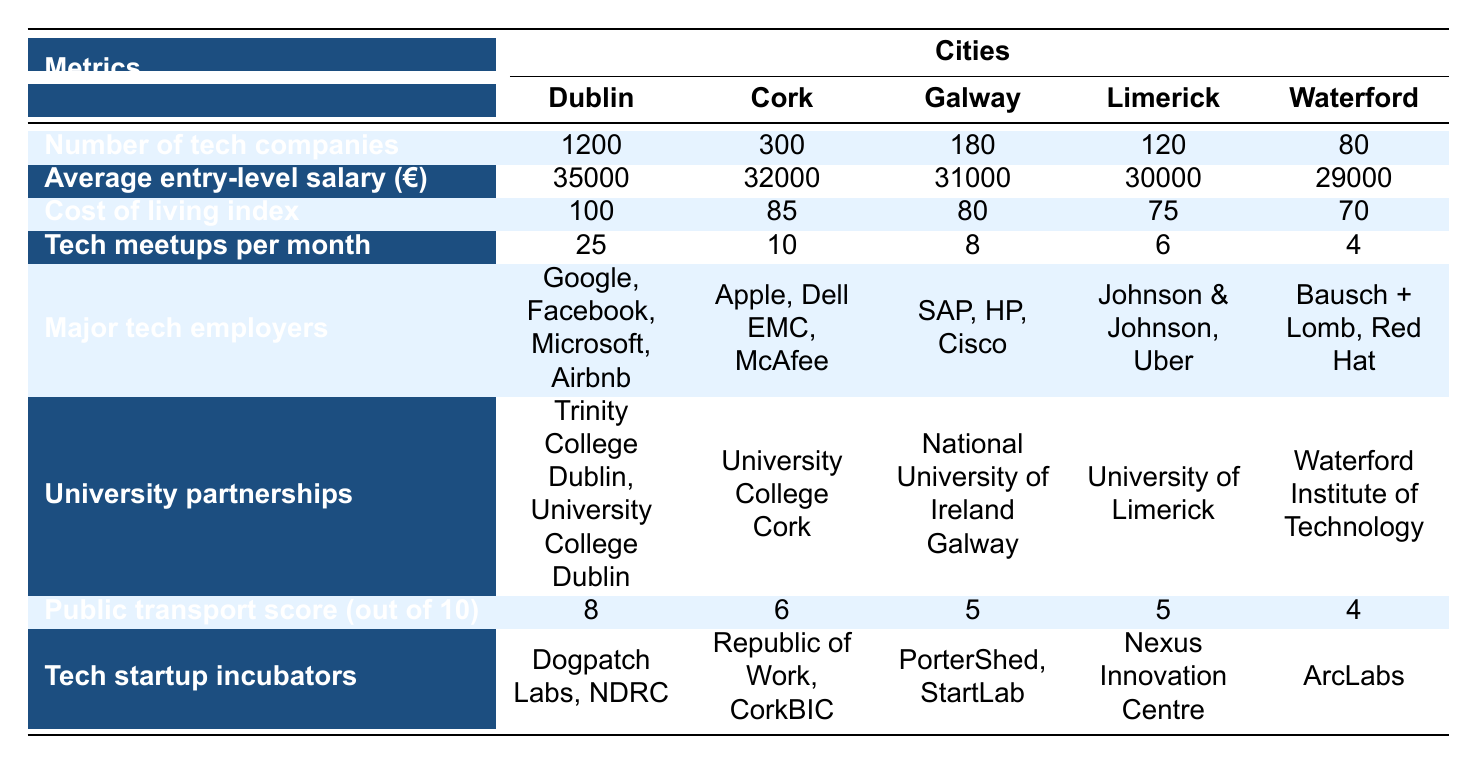What city has the highest number of tech companies? The table shows that Dublin has 1200 tech companies, which is higher than Cork (300), Galway (180), Limerick (120), and Waterford (80). Thus, Dublin has the highest number.
Answer: Dublin What is the average entry-level salary in Galway? The table indicates that the average entry-level salary in Galway is 31000 euros.
Answer: 31000 euros Is the cost of living index in Waterford lower than in Limerick? The table shows that Waterford has a cost of living index of 70 while Limerick's is 75. Since 70 is less than 75, the statement is true.
Answer: Yes How many tech meetups per month does Cork have compared to Dublin? Cork has 10 tech meetups per month, while Dublin has 25. The difference is 25 - 10 = 15, so Dublin has 15 more meetups than Cork.
Answer: 15 more meetups Which city has the worst public transport score? The public transport scores are: Dublin (8), Cork (6), Galway (5), Limerick (5), and Waterford (4). Waterford has the lowest score of 4, making it the city with the worst public transport score.
Answer: Waterford What is the average cost of living index of the cities in the table? The cost of living indices are: Dublin (100), Cork (85), Galway (80), Limerick (75), and Waterford (70). Summing these values gives 100 + 85 + 80 + 75 + 70 = 410, and dividing by 5 cities gives an average of 410 / 5 = 82.
Answer: 82 Does Cork have more tech startup incubators than Waterford? Cork has 2 tech startup incubators (Republic of Work, CorkBIC), while Waterford has 1 (ArcLabs). Since 2 is greater than 1, the statement is true.
Answer: Yes Which city has the highest average entry-level salary, and what is that salary? The table states that Dublin has the highest average entry-level salary of 35000 euros, which is greater than the salaries in Cork, Galway, Limerick, and Waterford.
Answer: 35000 euros in Dublin What is the combined number of tech companies in Galway and Limerick? According to the table, Galway has 180 tech companies and Limerick has 120. Adding these amounts together gives 180 + 120 = 300.
Answer: 300 companies 